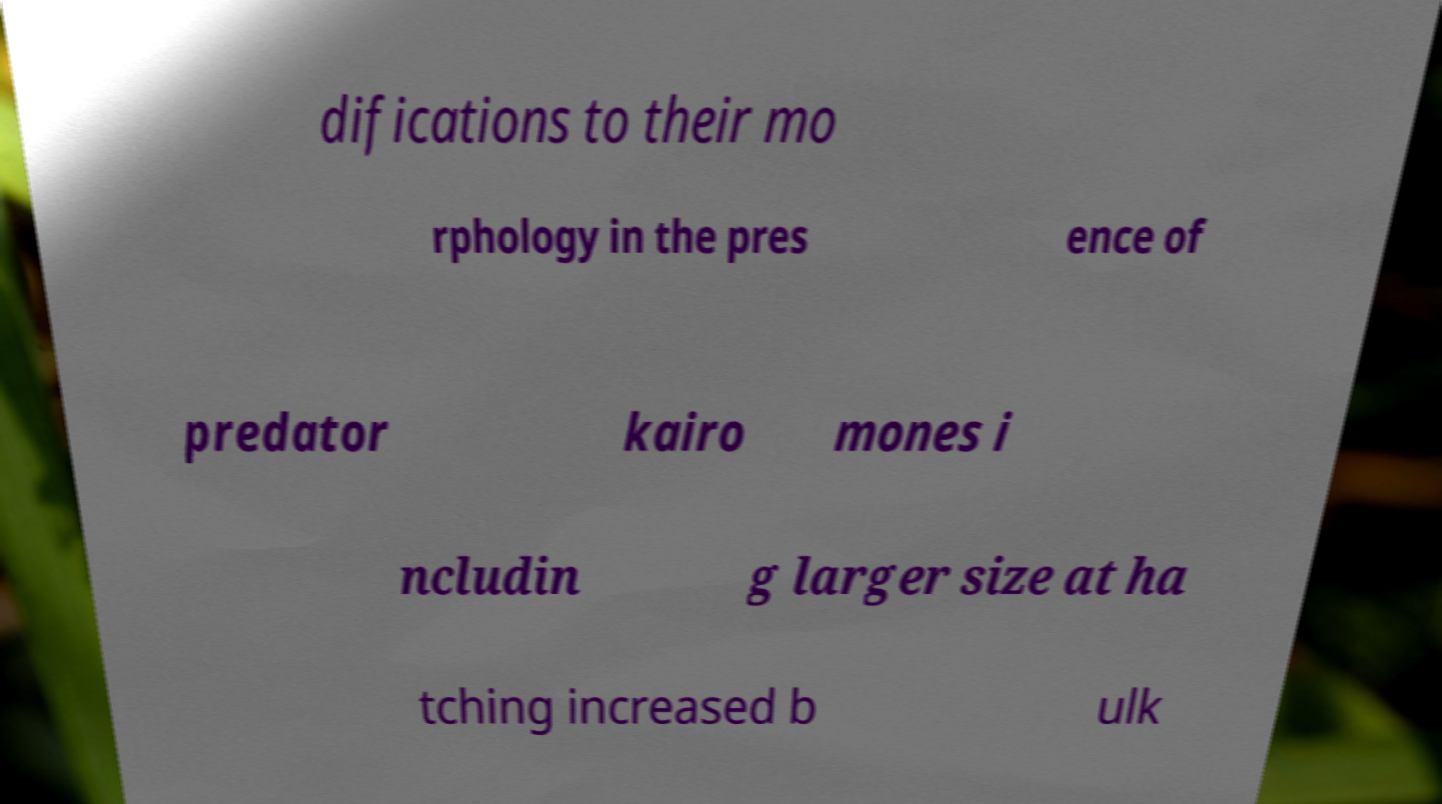Please read and relay the text visible in this image. What does it say? difications to their mo rphology in the pres ence of predator kairo mones i ncludin g larger size at ha tching increased b ulk 